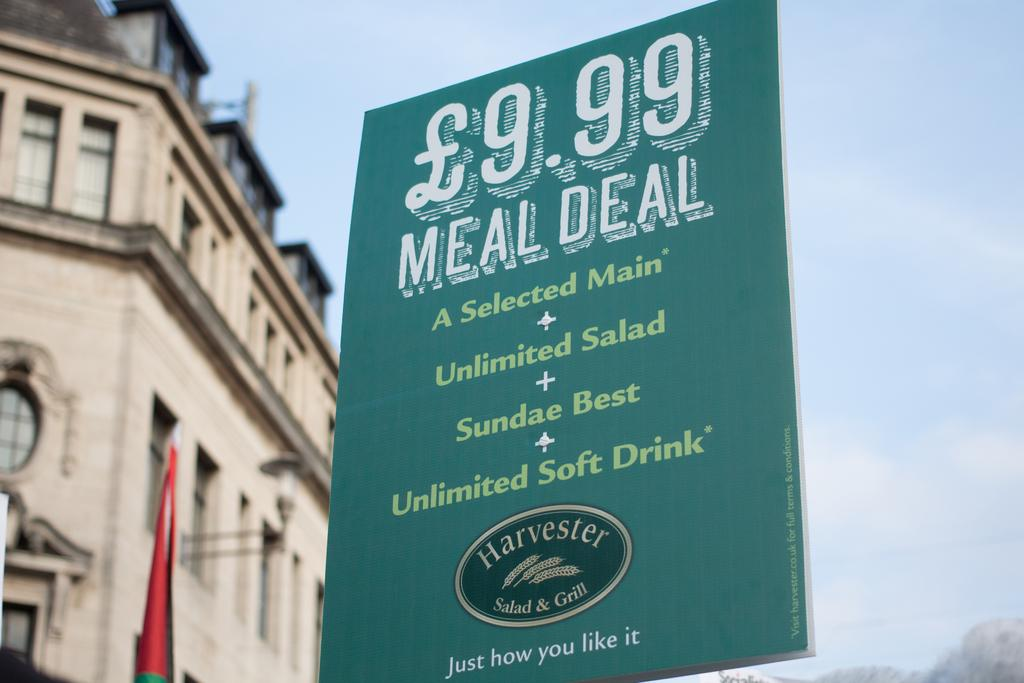What is the main object in the middle of the image? There is a banner in the middle of the image. What can be seen in the sky behind the banner? There are clouds in the sky behind the banner. What type of structures are on the left side of the image? There are buildings on the left side of the image. What type of honey is being used to write on the banner in the image? There is no honey present in the image, and therefore no such activity can be observed. 